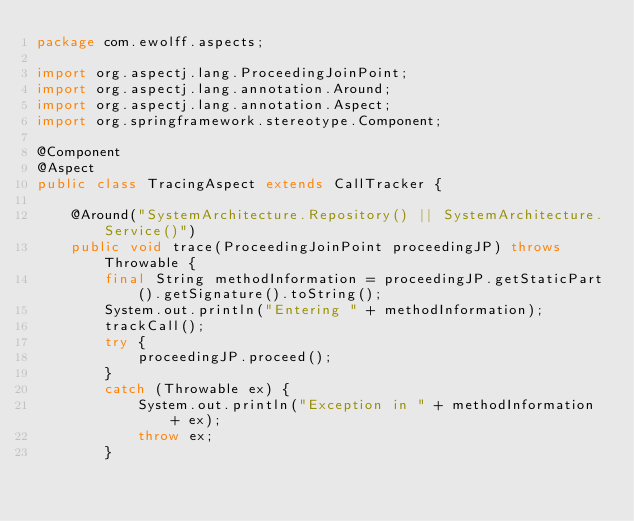<code> <loc_0><loc_0><loc_500><loc_500><_Java_>package com.ewolff.aspects;

import org.aspectj.lang.ProceedingJoinPoint;
import org.aspectj.lang.annotation.Around;
import org.aspectj.lang.annotation.Aspect;
import org.springframework.stereotype.Component;

@Component
@Aspect
public class TracingAspect extends CallTracker {

	@Around("SystemArchitecture.Repository() || SystemArchitecture.Service()")
	public void trace(ProceedingJoinPoint proceedingJP) throws Throwable {
		final String methodInformation = proceedingJP.getStaticPart().getSignature().toString();
		System.out.println("Entering " + methodInformation);
		trackCall();
		try {
			proceedingJP.proceed();
		}
		catch (Throwable ex) {
			System.out.println("Exception in " + methodInformation + ex);
			throw ex;
		}</code> 